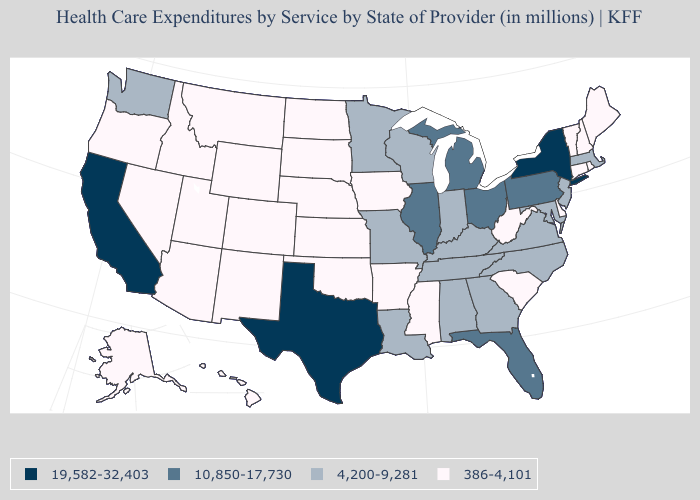Name the states that have a value in the range 4,200-9,281?
Keep it brief. Alabama, Georgia, Indiana, Kentucky, Louisiana, Maryland, Massachusetts, Minnesota, Missouri, New Jersey, North Carolina, Tennessee, Virginia, Washington, Wisconsin. Does New Jersey have the lowest value in the USA?
Short answer required. No. What is the value of Maryland?
Be succinct. 4,200-9,281. Name the states that have a value in the range 19,582-32,403?
Write a very short answer. California, New York, Texas. Name the states that have a value in the range 386-4,101?
Answer briefly. Alaska, Arizona, Arkansas, Colorado, Connecticut, Delaware, Hawaii, Idaho, Iowa, Kansas, Maine, Mississippi, Montana, Nebraska, Nevada, New Hampshire, New Mexico, North Dakota, Oklahoma, Oregon, Rhode Island, South Carolina, South Dakota, Utah, Vermont, West Virginia, Wyoming. What is the value of Mississippi?
Give a very brief answer. 386-4,101. What is the lowest value in the USA?
Quick response, please. 386-4,101. What is the lowest value in the Northeast?
Answer briefly. 386-4,101. What is the value of Kansas?
Answer briefly. 386-4,101. How many symbols are there in the legend?
Short answer required. 4. Name the states that have a value in the range 4,200-9,281?
Write a very short answer. Alabama, Georgia, Indiana, Kentucky, Louisiana, Maryland, Massachusetts, Minnesota, Missouri, New Jersey, North Carolina, Tennessee, Virginia, Washington, Wisconsin. Which states have the lowest value in the South?
Write a very short answer. Arkansas, Delaware, Mississippi, Oklahoma, South Carolina, West Virginia. Does Texas have a higher value than California?
Short answer required. No. Which states hav the highest value in the South?
Quick response, please. Texas. How many symbols are there in the legend?
Give a very brief answer. 4. 